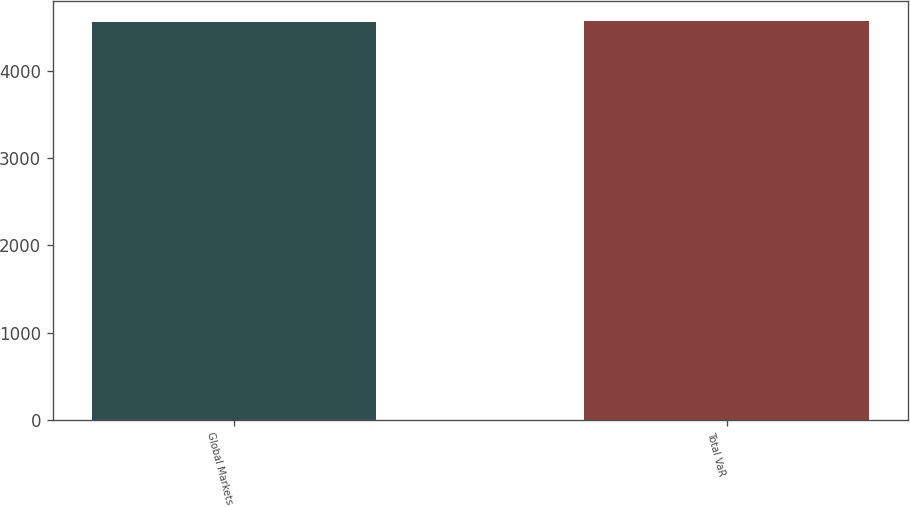<chart> <loc_0><loc_0><loc_500><loc_500><bar_chart><fcel>Global Markets<fcel>Total VaR<nl><fcel>4561<fcel>4577<nl></chart> 